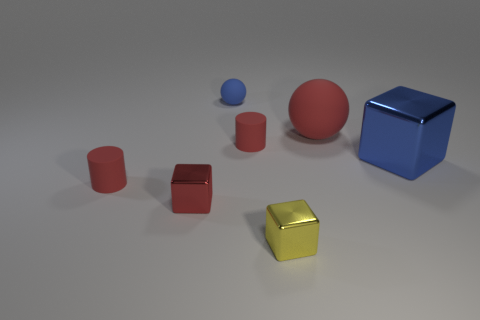There is another large shiny thing that is the same shape as the red metal thing; what is its color?
Offer a very short reply. Blue. There is a yellow thing that is the same shape as the small red metal thing; what is its size?
Ensure brevity in your answer.  Small. Are there any big blocks on the left side of the tiny blue rubber ball?
Your answer should be compact. No. Do the blue object in front of the big red sphere and the tiny yellow object have the same shape?
Offer a very short reply. Yes. There is a small block that is the same color as the big rubber object; what is it made of?
Ensure brevity in your answer.  Metal. What number of other rubber spheres have the same color as the small sphere?
Offer a very short reply. 0. What is the shape of the big object behind the thing to the right of the big ball?
Provide a short and direct response. Sphere. Are there any small cyan matte objects that have the same shape as the yellow metal thing?
Make the answer very short. No. There is a tiny matte sphere; is its color the same as the cube that is to the left of the yellow metallic cube?
Your answer should be compact. No. There is a shiny block that is the same color as the tiny matte sphere; what is its size?
Make the answer very short. Large. 